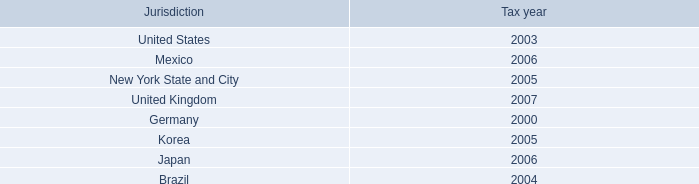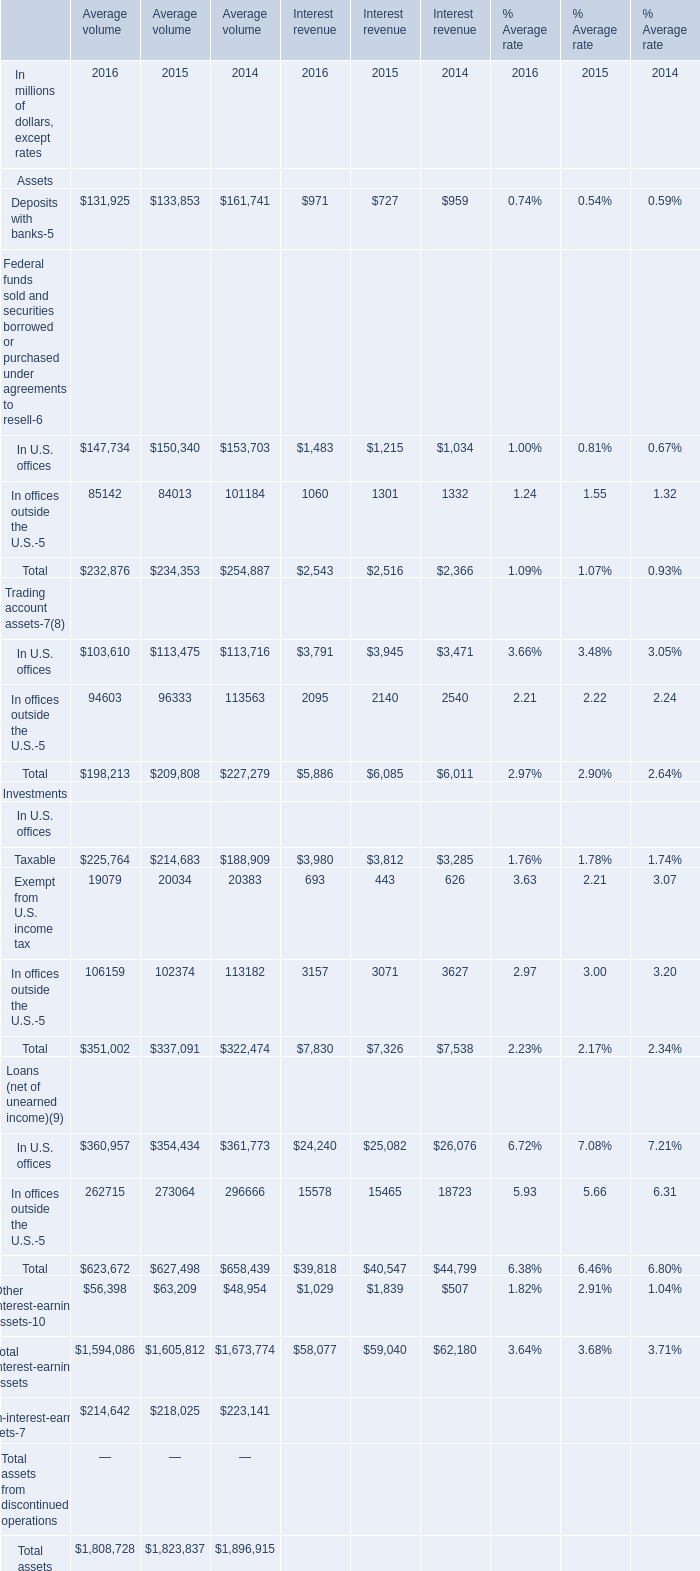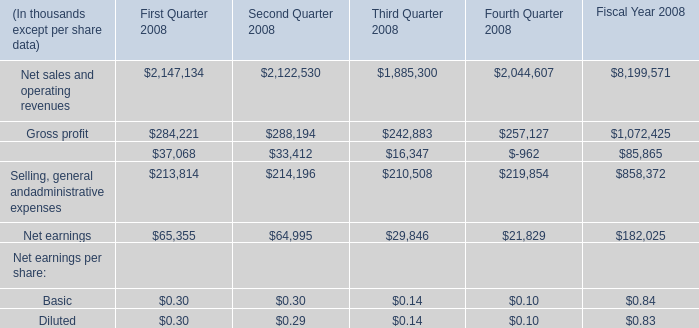What is the sum of Selling, general andadministrative expenses of Second Quarter 2008, Deposits with banks of Average volume 2015, and Total In U.S. offices of Interest revenue 2015 ? 
Computations: ((214196.0 + 133853.0) + 7326.0)
Answer: 355375.0. 